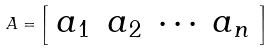<formula> <loc_0><loc_0><loc_500><loc_500>A = { \left [ \begin{array} { l l l l } { a _ { 1 } } & { a _ { 2 } } & { \cdots } & { a _ { n } } \end{array} \right ] }</formula> 